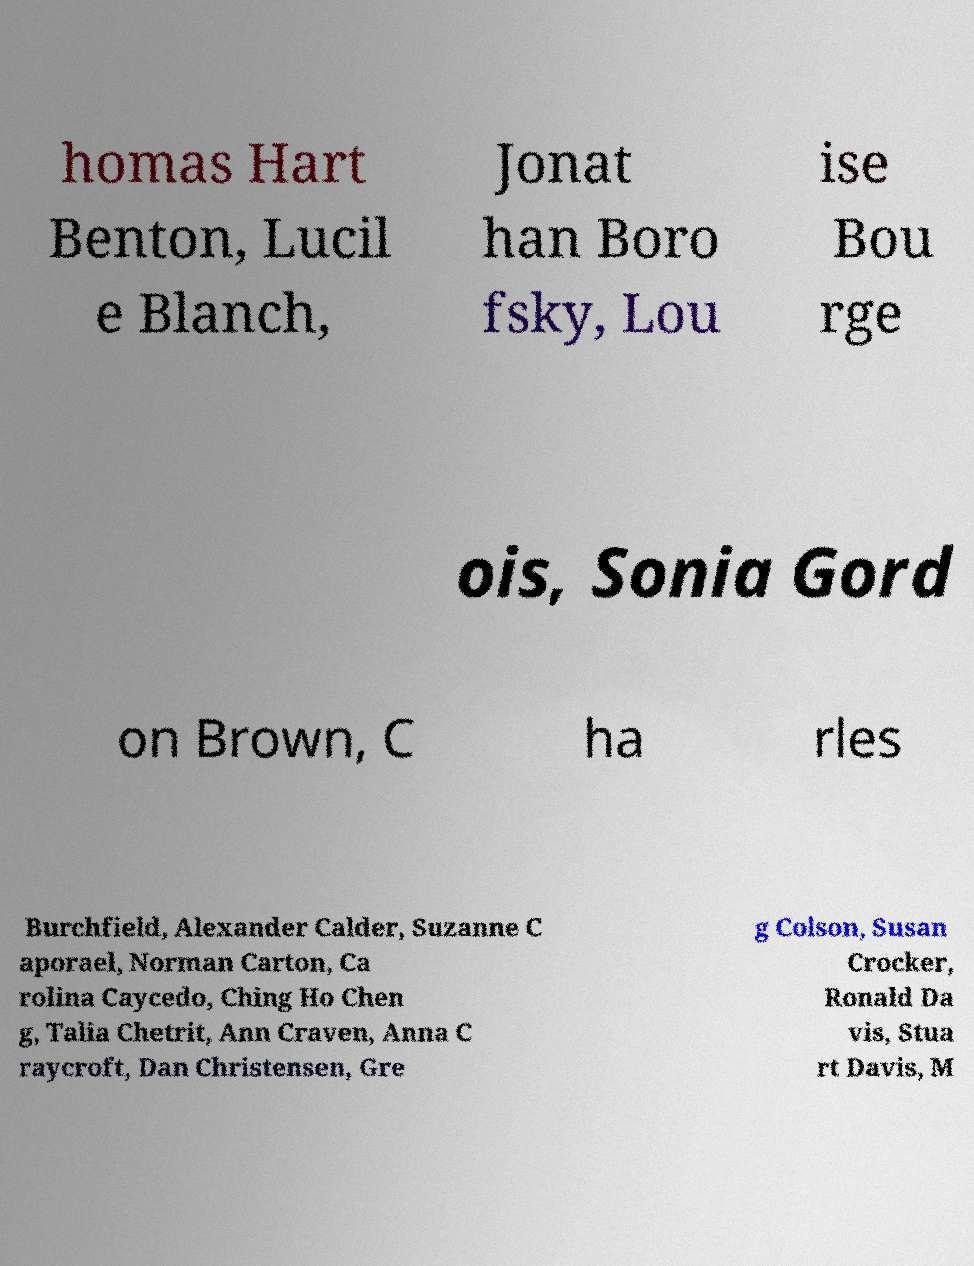What messages or text are displayed in this image? I need them in a readable, typed format. homas Hart Benton, Lucil e Blanch, Jonat han Boro fsky, Lou ise Bou rge ois, Sonia Gord on Brown, C ha rles Burchfield, Alexander Calder, Suzanne C aporael, Norman Carton, Ca rolina Caycedo, Ching Ho Chen g, Talia Chetrit, Ann Craven, Anna C raycroft, Dan Christensen, Gre g Colson, Susan Crocker, Ronald Da vis, Stua rt Davis, M 